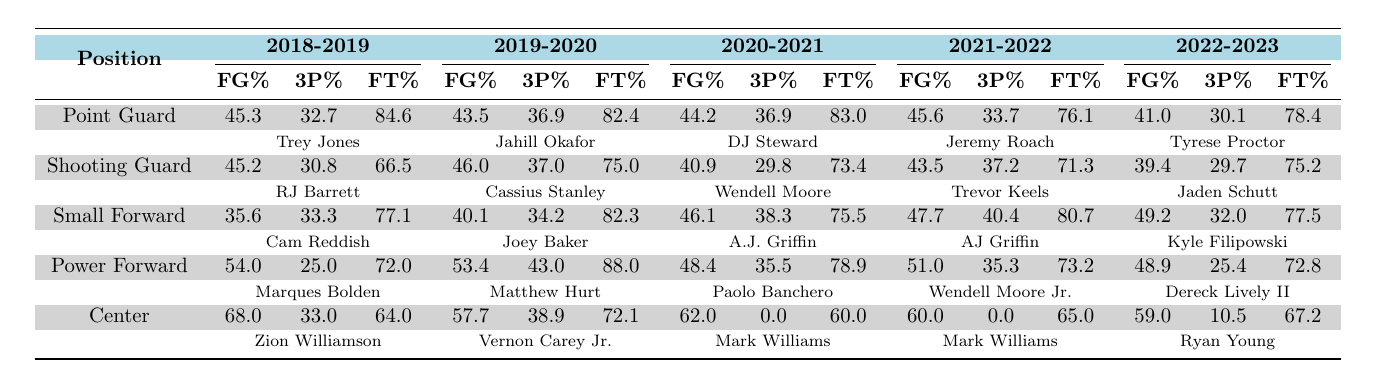What is the highest field goal percentage recorded for a player in the 2018-2019 season? Reviewing the table for the 2018-2019 season, the highest field goal percentage is 68.0%, recorded by Zion Williamson, who plays as a Center.
Answer: 68.0% Which player had the best free throw percentage in the 2019-2020 season? In the 2019-2020 season, the highest free throw percentage is 88.0% by Matthew Hurt, who plays as a Power Forward.
Answer: 88.0% What was the average field goal percentage for Point Guards over the five seasons? The Point Guards' field goal percentages over the five seasons are 45.3, 43.5, 44.2, 45.6, and 41.0. To find the average, sum them up (45.3 + 43.5 + 44.2 + 45.6 + 41.0 = 219.6), then divide by the number of seasons (219.6/5 = 43.92).
Answer: 43.92 Did any Center player record a three-point percentage above 30% in the 2020-2021 season? Looking at the 2020-2021 season, Mark Williams, who plays as a Center, has a three-point percentage of 0.0%, meaning no Center recorded a value above 30%.
Answer: No What is the difference between the highest and lowest free throw percentages among Power Forwards across all seasons? The highest free throw percentage among Power Forwards is 88.0% by Matthew Hurt (2019-2020), and the lowest is 72.0% by Marques Bolden (2018-2019). The difference is 88.0 - 72.0 = 16.0%.
Answer: 16.0% Which season saw the overall highest three-point percentage for the Small Forward position? Reviewing the Small Forward position across all seasons, the highest three-point percentage is 40.4%, recorded by AJ Griffin in the 2021-2022 season.
Answer: 40.4% In which season did the Shooting Guard position have the lowest average field goal percentage and what was that percentage? The Shooting Guards' field goal percentages are 45.2 (2018-2019), 46.0 (2019-2020), 40.9 (2020-2021), 43.5 (2021-2022), and 39.4 (2022-2023). The lowest is 39.4% in the 2022-2023 season.
Answer: 39.4% Who had the highest field goal percentage in the 2022-2023 season, among all positions? In the 2022-2023 season, Ryan Young, playing as a Center, recorded the highest field goal percentage of 59.0%.
Answer: 59.0% How does the average free throw percentage of Small Forwards compare to that of Shooting Guards over the five seasons? The Small Forwards' free throw percentages are 77.1, 82.3, 75.5, 80.7, and 77.5, with an average of (77.1 + 82.3 + 75.5 + 80.7 + 77.5)/5 = 78.62. The Shooting Guards have percentages of 66.5, 75.0, 73.4, 71.3, and 75.2, averaging (66.5 + 75.0 + 73.4 + 71.3 + 75.2)/5 = 72.48. Since 78.62 > 72.48, Small Forwards have a higher average.
Answer: Small Forwards have a higher average What is the trend observed for three-point percentages of Center players from the 2019-2020 season to the 2022-2023 season? The three-point percentages for Centers are 38.9 (2019-2020), 0.0 (2020-2021), 0.0 (2021-2022), and 10.5 (2022-2023). This shows a general decline with a slight increase in the last season, but it remains low.
Answer: Declining trend 